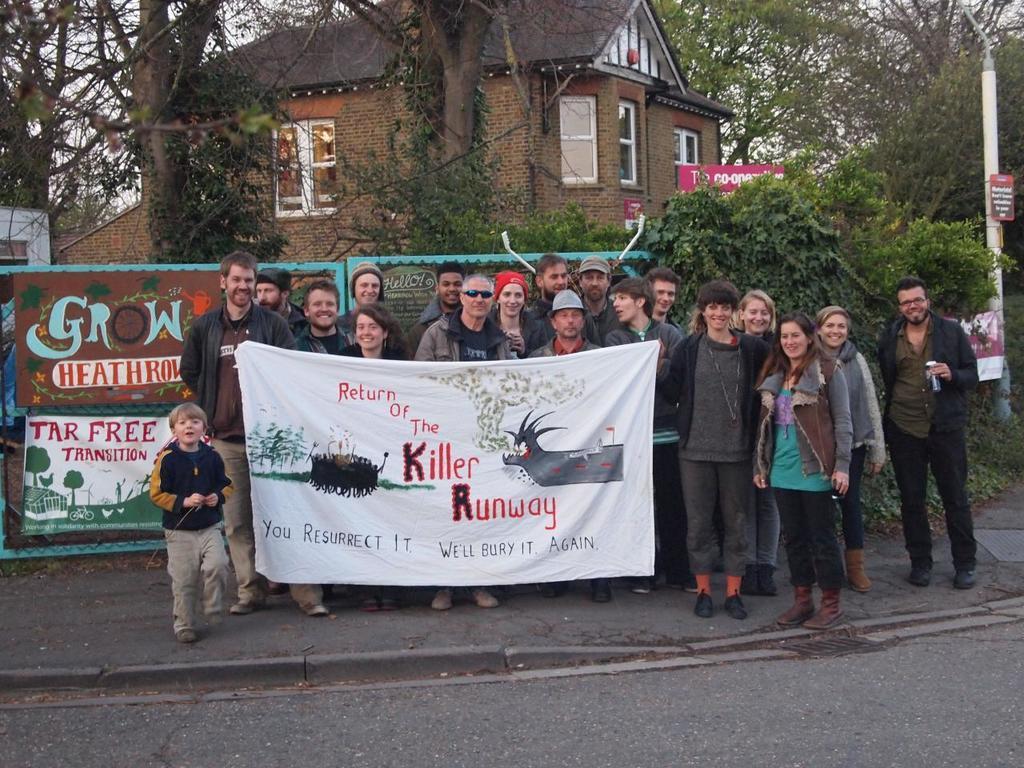Could you give a brief overview of what you see in this image? In this image we can see a building and it is having few windows. There are many trees in the image. There are many people in the image. There are few banners in the image. There is a road in the image. There are few advertising boards at the right side of the image. 